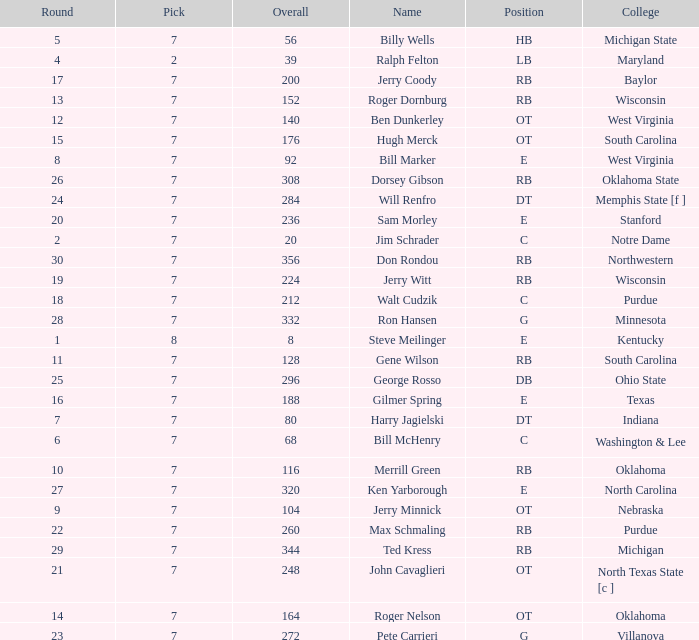What pick did George Rosso get drafted when the overall was less than 296? 0.0. 